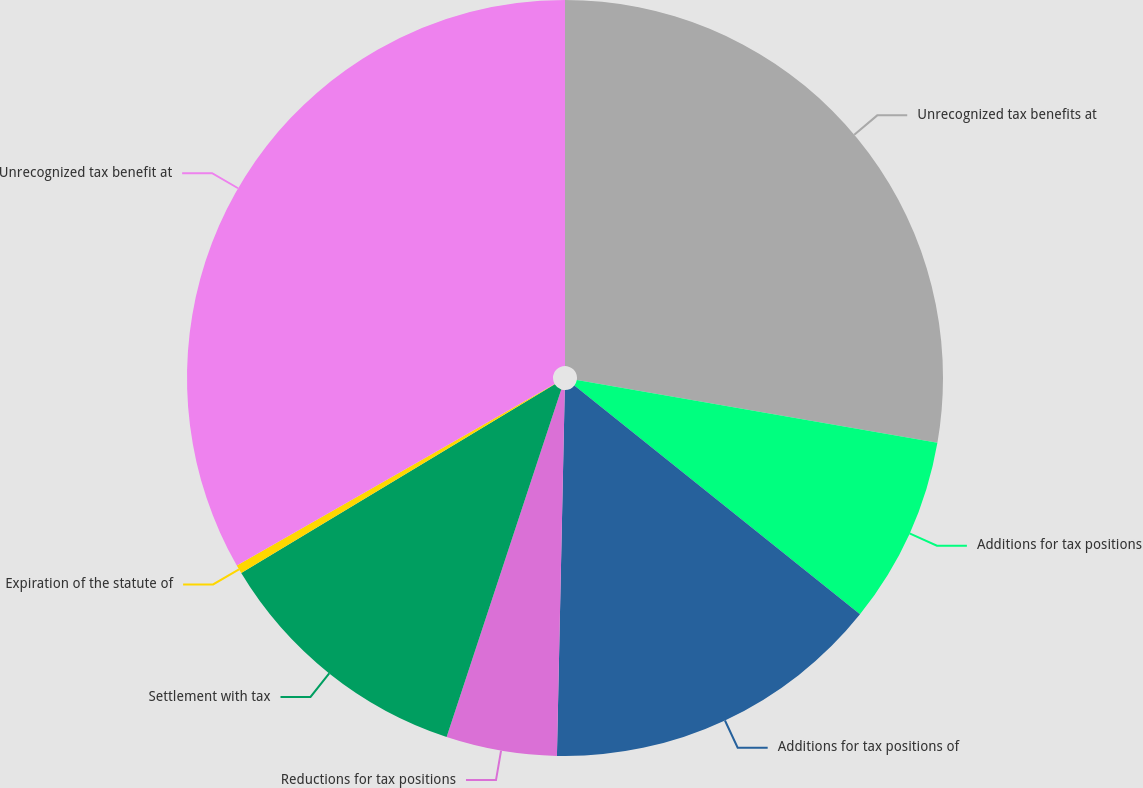Convert chart to OTSL. <chart><loc_0><loc_0><loc_500><loc_500><pie_chart><fcel>Unrecognized tax benefits at<fcel>Additions for tax positions<fcel>Additions for tax positions of<fcel>Reductions for tax positions<fcel>Settlement with tax<fcel>Expiration of the statute of<fcel>Unrecognized tax benefit at<nl><fcel>27.74%<fcel>8.01%<fcel>14.59%<fcel>4.73%<fcel>11.3%<fcel>0.37%<fcel>33.26%<nl></chart> 